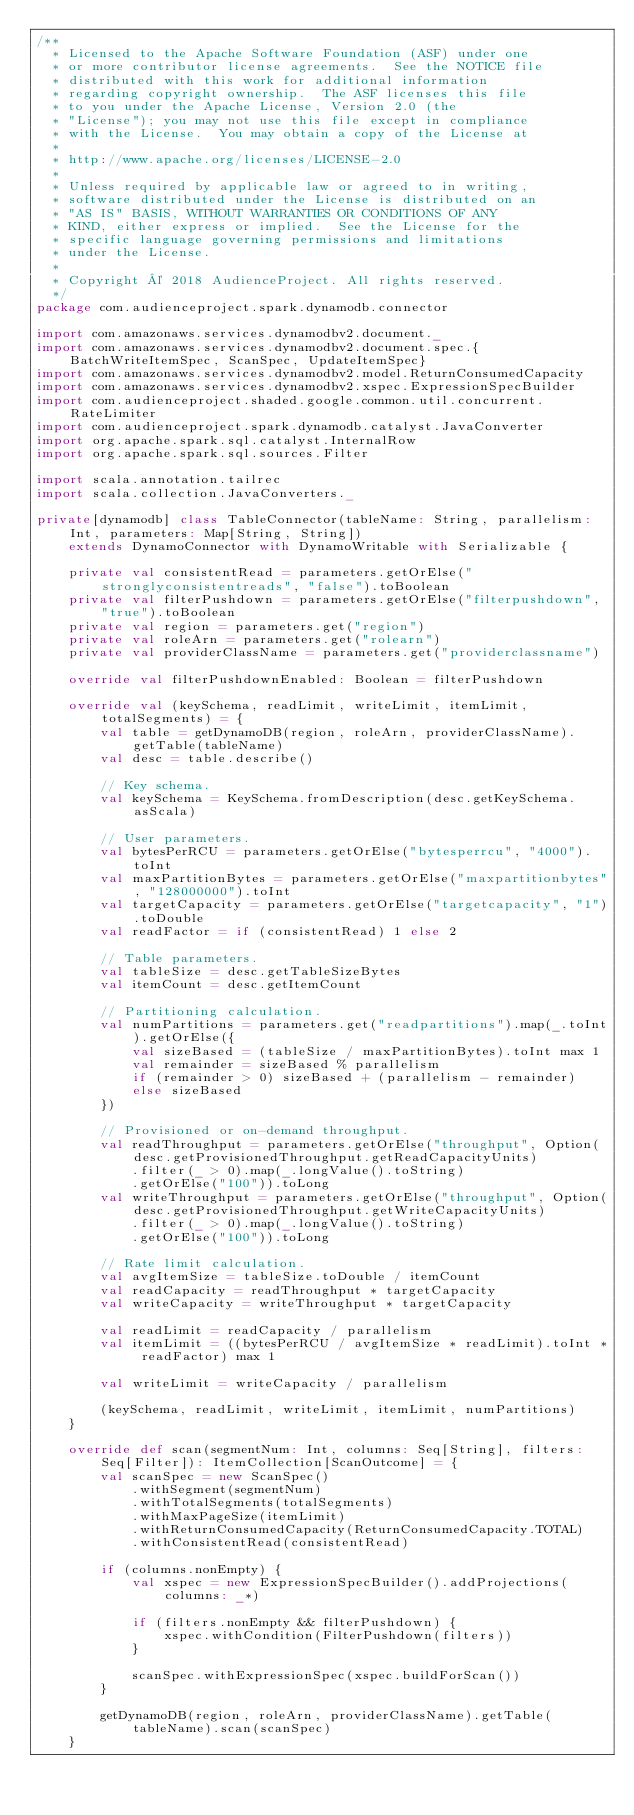Convert code to text. <code><loc_0><loc_0><loc_500><loc_500><_Scala_>/**
  * Licensed to the Apache Software Foundation (ASF) under one
  * or more contributor license agreements.  See the NOTICE file
  * distributed with this work for additional information
  * regarding copyright ownership.  The ASF licenses this file
  * to you under the Apache License, Version 2.0 (the
  * "License"); you may not use this file except in compliance
  * with the License.  You may obtain a copy of the License at
  *
  * http://www.apache.org/licenses/LICENSE-2.0
  *
  * Unless required by applicable law or agreed to in writing,
  * software distributed under the License is distributed on an
  * "AS IS" BASIS, WITHOUT WARRANTIES OR CONDITIONS OF ANY
  * KIND, either express or implied.  See the License for the
  * specific language governing permissions and limitations
  * under the License.
  *
  * Copyright © 2018 AudienceProject. All rights reserved.
  */
package com.audienceproject.spark.dynamodb.connector

import com.amazonaws.services.dynamodbv2.document._
import com.amazonaws.services.dynamodbv2.document.spec.{BatchWriteItemSpec, ScanSpec, UpdateItemSpec}
import com.amazonaws.services.dynamodbv2.model.ReturnConsumedCapacity
import com.amazonaws.services.dynamodbv2.xspec.ExpressionSpecBuilder
import com.audienceproject.shaded.google.common.util.concurrent.RateLimiter
import com.audienceproject.spark.dynamodb.catalyst.JavaConverter
import org.apache.spark.sql.catalyst.InternalRow
import org.apache.spark.sql.sources.Filter

import scala.annotation.tailrec
import scala.collection.JavaConverters._

private[dynamodb] class TableConnector(tableName: String, parallelism: Int, parameters: Map[String, String])
    extends DynamoConnector with DynamoWritable with Serializable {

    private val consistentRead = parameters.getOrElse("stronglyconsistentreads", "false").toBoolean
    private val filterPushdown = parameters.getOrElse("filterpushdown", "true").toBoolean
    private val region = parameters.get("region")
    private val roleArn = parameters.get("rolearn")
    private val providerClassName = parameters.get("providerclassname")

    override val filterPushdownEnabled: Boolean = filterPushdown

    override val (keySchema, readLimit, writeLimit, itemLimit, totalSegments) = {
        val table = getDynamoDB(region, roleArn, providerClassName).getTable(tableName)
        val desc = table.describe()

        // Key schema.
        val keySchema = KeySchema.fromDescription(desc.getKeySchema.asScala)

        // User parameters.
        val bytesPerRCU = parameters.getOrElse("bytesperrcu", "4000").toInt
        val maxPartitionBytes = parameters.getOrElse("maxpartitionbytes", "128000000").toInt
        val targetCapacity = parameters.getOrElse("targetcapacity", "1").toDouble
        val readFactor = if (consistentRead) 1 else 2

        // Table parameters.
        val tableSize = desc.getTableSizeBytes
        val itemCount = desc.getItemCount

        // Partitioning calculation.
        val numPartitions = parameters.get("readpartitions").map(_.toInt).getOrElse({
            val sizeBased = (tableSize / maxPartitionBytes).toInt max 1
            val remainder = sizeBased % parallelism
            if (remainder > 0) sizeBased + (parallelism - remainder)
            else sizeBased
        })

        // Provisioned or on-demand throughput.
        val readThroughput = parameters.getOrElse("throughput", Option(desc.getProvisionedThroughput.getReadCapacityUnits)
            .filter(_ > 0).map(_.longValue().toString)
            .getOrElse("100")).toLong
        val writeThroughput = parameters.getOrElse("throughput", Option(desc.getProvisionedThroughput.getWriteCapacityUnits)
            .filter(_ > 0).map(_.longValue().toString)
            .getOrElse("100")).toLong

        // Rate limit calculation.
        val avgItemSize = tableSize.toDouble / itemCount
        val readCapacity = readThroughput * targetCapacity
        val writeCapacity = writeThroughput * targetCapacity

        val readLimit = readCapacity / parallelism
        val itemLimit = ((bytesPerRCU / avgItemSize * readLimit).toInt * readFactor) max 1

        val writeLimit = writeCapacity / parallelism

        (keySchema, readLimit, writeLimit, itemLimit, numPartitions)
    }

    override def scan(segmentNum: Int, columns: Seq[String], filters: Seq[Filter]): ItemCollection[ScanOutcome] = {
        val scanSpec = new ScanSpec()
            .withSegment(segmentNum)
            .withTotalSegments(totalSegments)
            .withMaxPageSize(itemLimit)
            .withReturnConsumedCapacity(ReturnConsumedCapacity.TOTAL)
            .withConsistentRead(consistentRead)

        if (columns.nonEmpty) {
            val xspec = new ExpressionSpecBuilder().addProjections(columns: _*)

            if (filters.nonEmpty && filterPushdown) {
                xspec.withCondition(FilterPushdown(filters))
            }

            scanSpec.withExpressionSpec(xspec.buildForScan())
        }

        getDynamoDB(region, roleArn, providerClassName).getTable(tableName).scan(scanSpec)
    }
</code> 